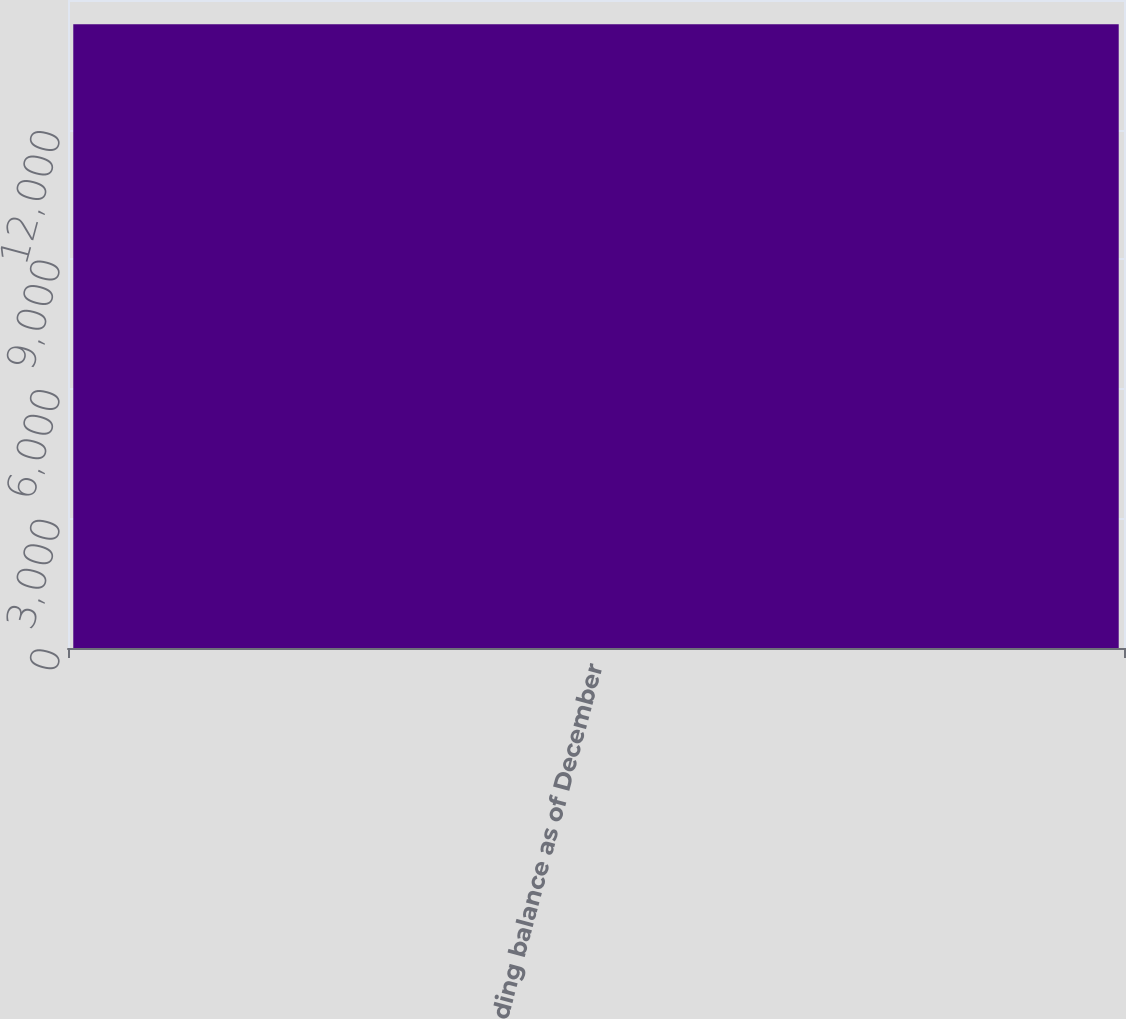Convert chart. <chart><loc_0><loc_0><loc_500><loc_500><bar_chart><fcel>Ending balance as of December<nl><fcel>14436<nl></chart> 